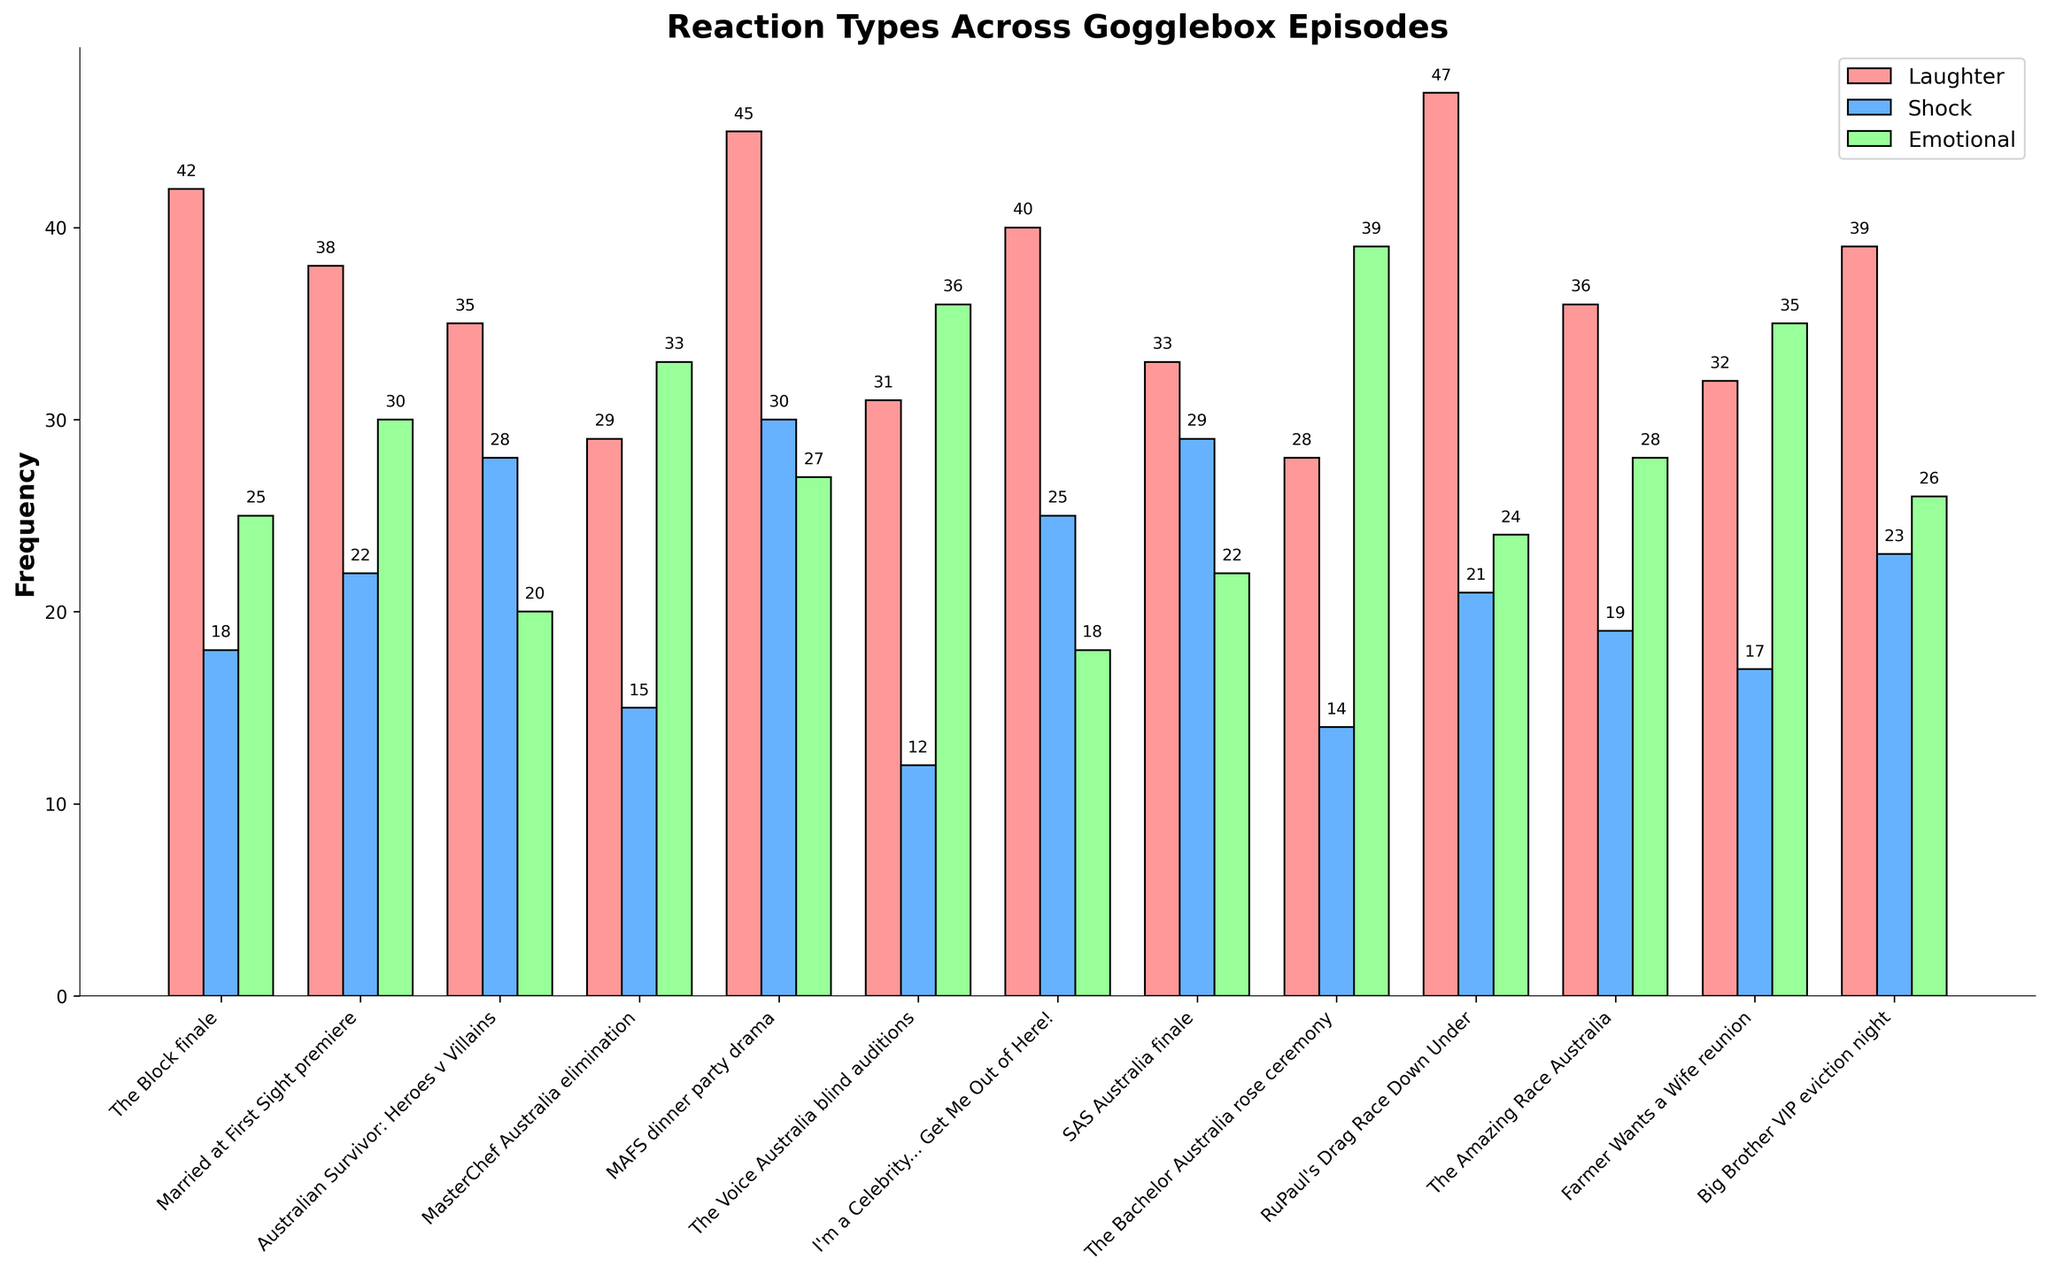What's the episode with the highest frequency of emotional reactions? By examining the height of the green bars representing emotional reactions, we can see that "The Bachelor Australia rose ceremony" has the highest bar for emotional reactions.
Answer: The Bachelor Australia rose ceremony Which episode featured the highest shock reactions? The blue bars represent shock reactions. The highest blue bar corresponds to "MAFS dinner party drama".
Answer: MAFS dinner party drama Compare the reaction types for "RuPaul's Drag Race Down Under". Which reaction type is highest and by how much? For "RuPaul's Drag Race Down Under", we see that the red bar (laughter) is the highest. Laughter has a frequency of 47, while shock is 21, and emotional is 24. The difference between laughter and the next highest reaction (emotional) is 47 - 24 = 23.
Answer: Laughter by 23 What is the sum of all laughter reactions across all episodes? Add up all the laughter frequencies: 42 + 38 + 35 + 29 + 45 + 31 + 40 + 33 + 28 + 47 + 36 + 32 + 39. The total is 475.
Answer: 475 What is the total frequency of reactions for "The Voice Australia blind auditions"? Add up the frequencies of laughter, shock, and emotional reactions: 31 (laughter) + 12 (shock) + 36 (emotional) = 79.
Answer: 79 Which two episodes have the same frequency of emotional reactions, and what is this frequency? From the green bars, we see that "The Voice Australia blind auditions" and "Farmer Wants a Wife reunion" both have an emotional reaction frequency of 36.
Answer: The Voice Australia blind auditions and Farmer Wants a Wife reunion with 36 